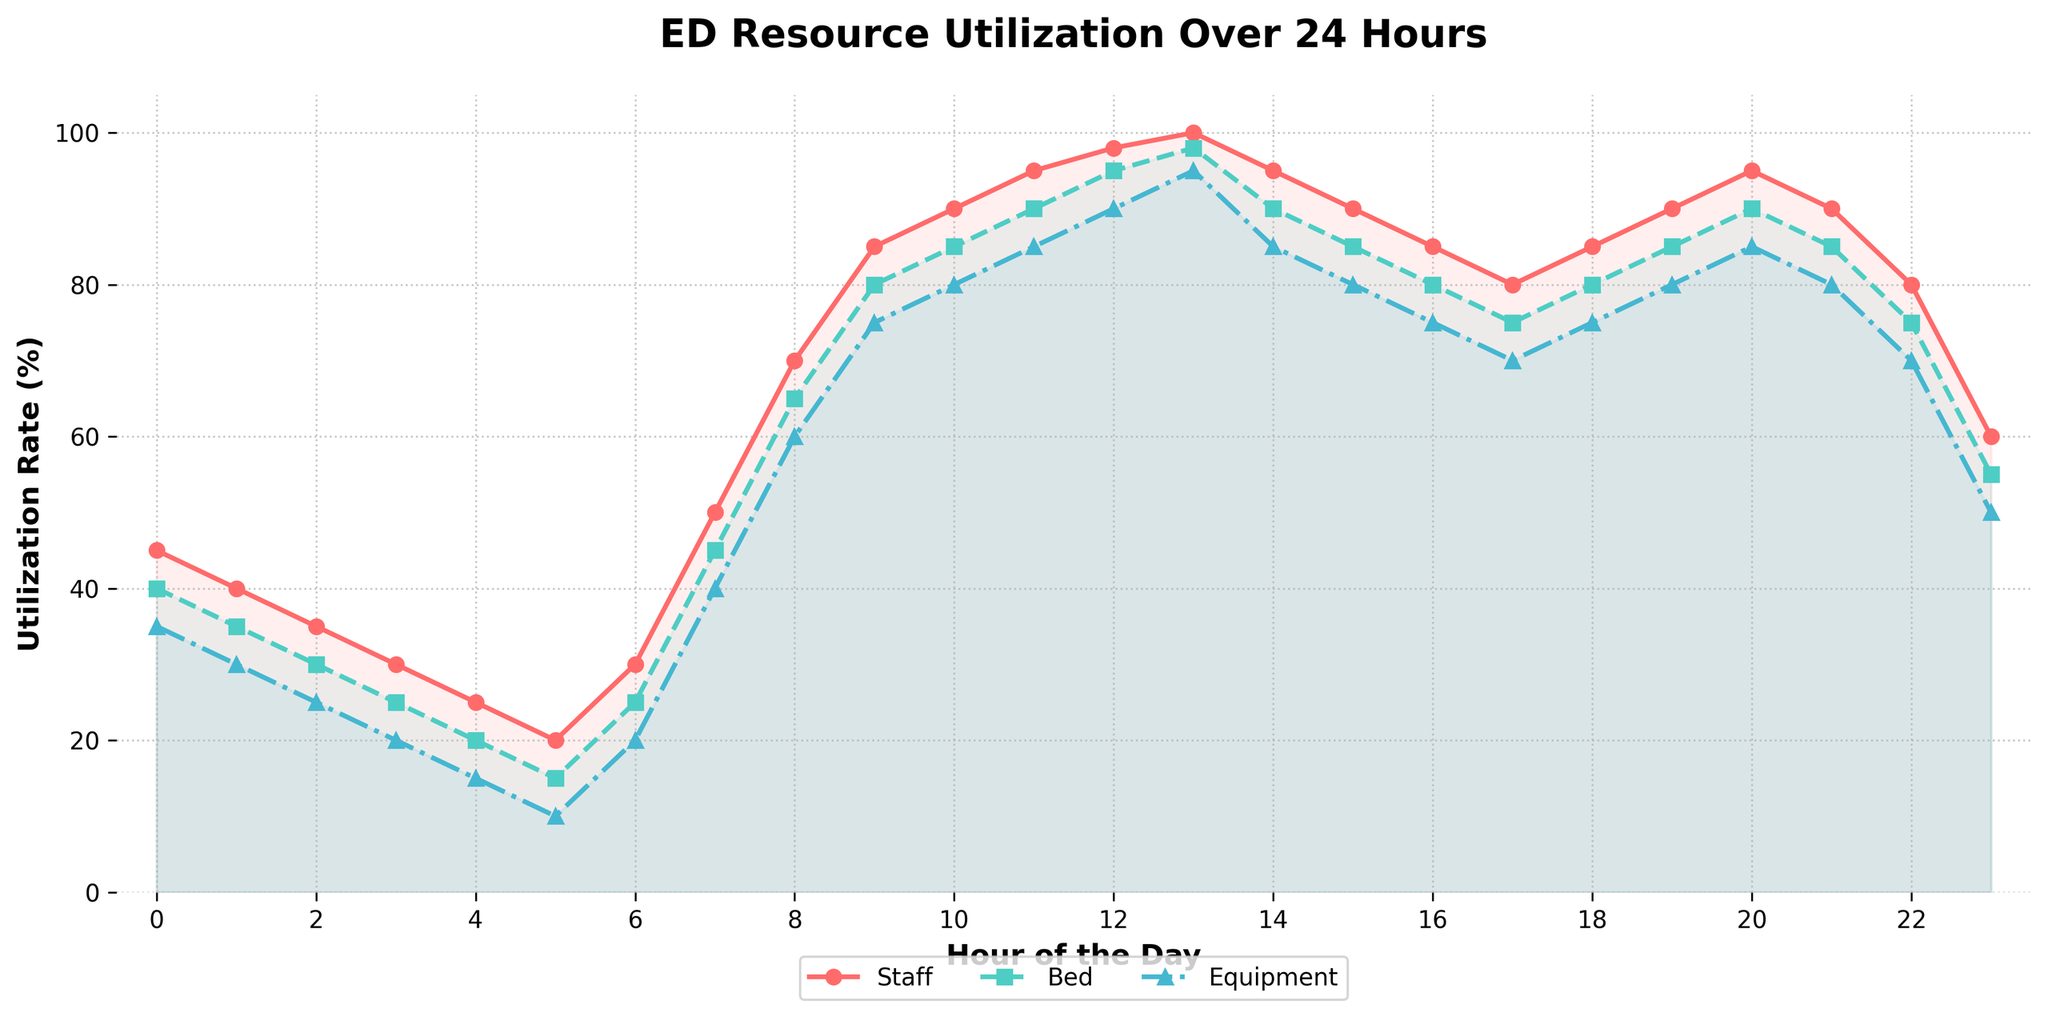What time of day does staff utilization reach its peak? The highest point on the red line representing staff utilization is observed at hour 13 (1 PM), where it reaches 100%.
Answer: Hour 13 How do bed utilization rates compare between 9 AM and 9 PM? At 9 AM, bed utilization is 80%, and at 9 PM, it is 85%. By comparing these values, we see that bed utilization is higher at 9 PM.
Answer: Bed utilization is higher at 9 PM What is the difference in equipment utilization between 4 AM and 4 PM? Equipment utilization at 4 AM is 15%, and at 4 PM, it is 85%. The difference is calculated as 85% - 15%, which equals 70%.
Answer: 70% On average, what is the utilization rate for beds during the hours between 6 AM and 6 PM? Bed utilization rates from 6 AM to 6 PM are: 25, 45, 65, 80, 85, 90, 95, 98, 90, 85, 80, 75. Sum these values = 913. There are 12 data points. So, average = 913/12 = 76.08%.
Answer: 76.08% Which resource shows the most significant increase in utilization from 1 AM to 8 AM? From the chart, staff utilization increases from 40% to 70% (30% increase), bed utilization from 35% to 65% (30% increase), and equipment utilization from 30% to 60% (30% increase). Thus, all resources show an equal rise of 30%.
Answer: All resources equally What is the utilization rate of equipment at 7 PM? The blue dashed line representing equipment utilization at 7 PM (hour 19) reaches 70%.
Answer: 70% During which hour is the difference between bed and equipment utilization rates the smallest? By visually comparing the green (bed) and blue (equipment) lines, the smallest difference occurs at 13 (1 PM), where bed utilization is 98% and equipment utilization is 95%, making the difference 3%.
Answer: Hour 13 What’s the median utilization rate of staff during the first half of the day? Staff utilization rates from 0 to 11 hours are: 45, 40, 35, 30, 25, 20, 30, 50, 70, 85, 90, 95. Ordering these: 20, 25, 30, 30, 35, 40, 45, 50, 70, 85, 90, 95. The median value, being in the middle, is the average of 6th and 7th values, (40+45)/2 = 42.5.
Answer: 42.5% When observing all three resources, during which hour do they have the highest combined utilization rate? Adding the utilization rates for each hour, the highest combined rate appears at hour 13 (1 PM): Staff (100%) + Bed (98%) + Equipment (95%) = 293%.
Answer: Hour 13 How does the utilization rate of beds change from midnight to 6 AM? Bed utilization at midnight (hour 0) is 40%, and it drops to 25%, 20%, 15%, and finally to 10% by 6 AM. This shows a consistent downward trend.
Answer: It decreases from 40% to 10% 